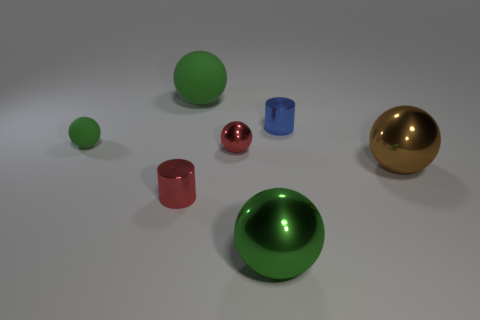What might be the context or purpose of this arrangement of objects? This arrangement of objects seems to be a demonstrative setup, potentially used to showcase the differences in surface textures, color, and shapes. It could be a part of a visual study or an exercise in 3D rendering to simulate how various materials interact with a given light environment. 